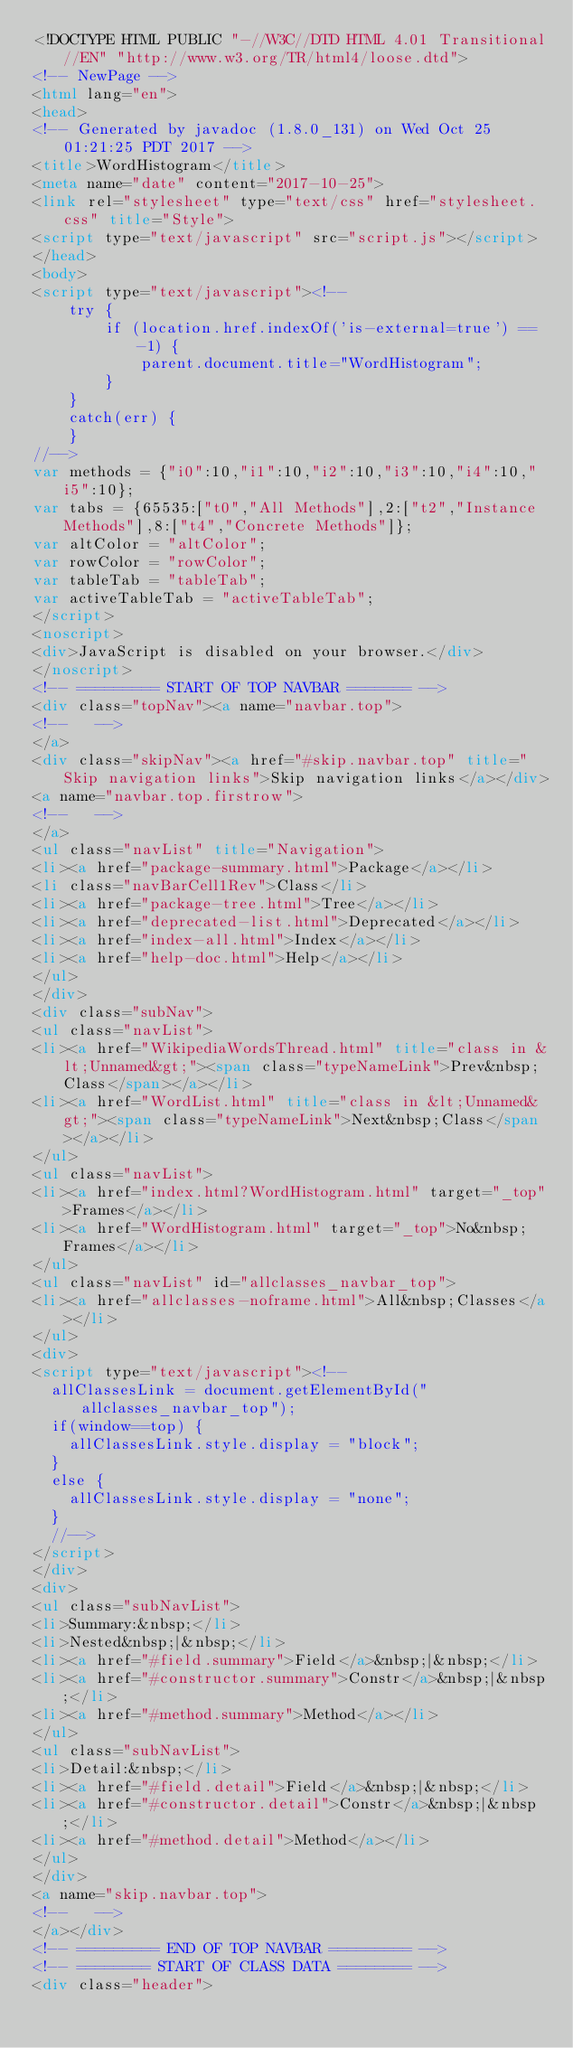<code> <loc_0><loc_0><loc_500><loc_500><_HTML_><!DOCTYPE HTML PUBLIC "-//W3C//DTD HTML 4.01 Transitional//EN" "http://www.w3.org/TR/html4/loose.dtd">
<!-- NewPage -->
<html lang="en">
<head>
<!-- Generated by javadoc (1.8.0_131) on Wed Oct 25 01:21:25 PDT 2017 -->
<title>WordHistogram</title>
<meta name="date" content="2017-10-25">
<link rel="stylesheet" type="text/css" href="stylesheet.css" title="Style">
<script type="text/javascript" src="script.js"></script>
</head>
<body>
<script type="text/javascript"><!--
    try {
        if (location.href.indexOf('is-external=true') == -1) {
            parent.document.title="WordHistogram";
        }
    }
    catch(err) {
    }
//-->
var methods = {"i0":10,"i1":10,"i2":10,"i3":10,"i4":10,"i5":10};
var tabs = {65535:["t0","All Methods"],2:["t2","Instance Methods"],8:["t4","Concrete Methods"]};
var altColor = "altColor";
var rowColor = "rowColor";
var tableTab = "tableTab";
var activeTableTab = "activeTableTab";
</script>
<noscript>
<div>JavaScript is disabled on your browser.</div>
</noscript>
<!-- ========= START OF TOP NAVBAR ======= -->
<div class="topNav"><a name="navbar.top">
<!--   -->
</a>
<div class="skipNav"><a href="#skip.navbar.top" title="Skip navigation links">Skip navigation links</a></div>
<a name="navbar.top.firstrow">
<!--   -->
</a>
<ul class="navList" title="Navigation">
<li><a href="package-summary.html">Package</a></li>
<li class="navBarCell1Rev">Class</li>
<li><a href="package-tree.html">Tree</a></li>
<li><a href="deprecated-list.html">Deprecated</a></li>
<li><a href="index-all.html">Index</a></li>
<li><a href="help-doc.html">Help</a></li>
</ul>
</div>
<div class="subNav">
<ul class="navList">
<li><a href="WikipediaWordsThread.html" title="class in &lt;Unnamed&gt;"><span class="typeNameLink">Prev&nbsp;Class</span></a></li>
<li><a href="WordList.html" title="class in &lt;Unnamed&gt;"><span class="typeNameLink">Next&nbsp;Class</span></a></li>
</ul>
<ul class="navList">
<li><a href="index.html?WordHistogram.html" target="_top">Frames</a></li>
<li><a href="WordHistogram.html" target="_top">No&nbsp;Frames</a></li>
</ul>
<ul class="navList" id="allclasses_navbar_top">
<li><a href="allclasses-noframe.html">All&nbsp;Classes</a></li>
</ul>
<div>
<script type="text/javascript"><!--
  allClassesLink = document.getElementById("allclasses_navbar_top");
  if(window==top) {
    allClassesLink.style.display = "block";
  }
  else {
    allClassesLink.style.display = "none";
  }
  //-->
</script>
</div>
<div>
<ul class="subNavList">
<li>Summary:&nbsp;</li>
<li>Nested&nbsp;|&nbsp;</li>
<li><a href="#field.summary">Field</a>&nbsp;|&nbsp;</li>
<li><a href="#constructor.summary">Constr</a>&nbsp;|&nbsp;</li>
<li><a href="#method.summary">Method</a></li>
</ul>
<ul class="subNavList">
<li>Detail:&nbsp;</li>
<li><a href="#field.detail">Field</a>&nbsp;|&nbsp;</li>
<li><a href="#constructor.detail">Constr</a>&nbsp;|&nbsp;</li>
<li><a href="#method.detail">Method</a></li>
</ul>
</div>
<a name="skip.navbar.top">
<!--   -->
</a></div>
<!-- ========= END OF TOP NAVBAR ========= -->
<!-- ======== START OF CLASS DATA ======== -->
<div class="header"></code> 